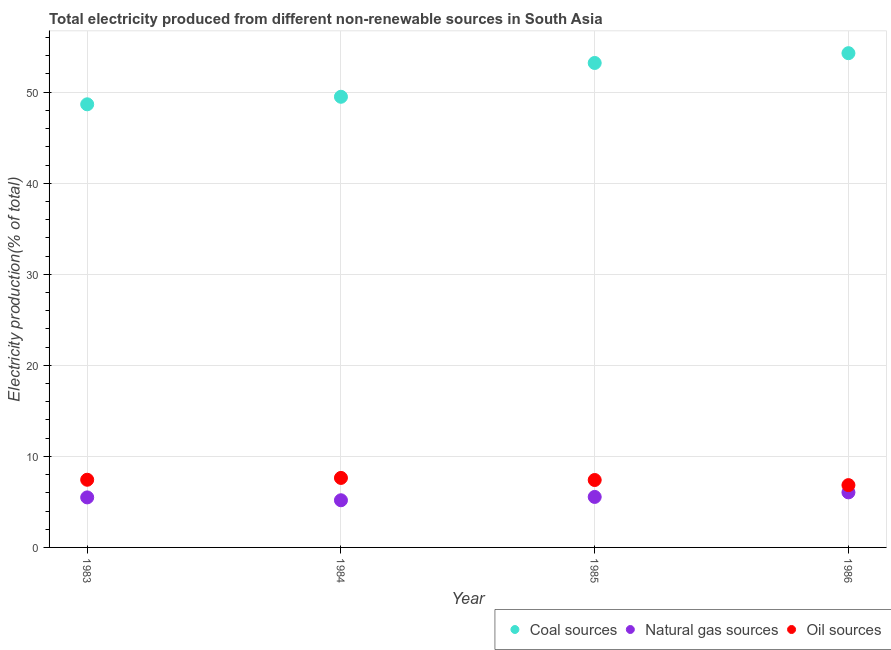How many different coloured dotlines are there?
Provide a succinct answer. 3. What is the percentage of electricity produced by natural gas in 1986?
Your answer should be compact. 6.05. Across all years, what is the maximum percentage of electricity produced by oil sources?
Your response must be concise. 7.63. Across all years, what is the minimum percentage of electricity produced by coal?
Ensure brevity in your answer.  48.67. In which year was the percentage of electricity produced by coal maximum?
Provide a short and direct response. 1986. What is the total percentage of electricity produced by natural gas in the graph?
Your response must be concise. 22.27. What is the difference between the percentage of electricity produced by oil sources in 1984 and that in 1986?
Offer a very short reply. 0.79. What is the difference between the percentage of electricity produced by natural gas in 1983 and the percentage of electricity produced by oil sources in 1984?
Your response must be concise. -2.14. What is the average percentage of electricity produced by oil sources per year?
Your answer should be very brief. 7.33. In the year 1985, what is the difference between the percentage of electricity produced by natural gas and percentage of electricity produced by oil sources?
Make the answer very short. -1.86. What is the ratio of the percentage of electricity produced by natural gas in 1983 to that in 1986?
Your response must be concise. 0.91. Is the percentage of electricity produced by natural gas in 1984 less than that in 1986?
Offer a very short reply. Yes. What is the difference between the highest and the second highest percentage of electricity produced by oil sources?
Ensure brevity in your answer.  0.2. What is the difference between the highest and the lowest percentage of electricity produced by coal?
Your response must be concise. 5.62. In how many years, is the percentage of electricity produced by coal greater than the average percentage of electricity produced by coal taken over all years?
Offer a very short reply. 2. Is the sum of the percentage of electricity produced by coal in 1985 and 1986 greater than the maximum percentage of electricity produced by oil sources across all years?
Keep it short and to the point. Yes. How many dotlines are there?
Offer a terse response. 3. What is the title of the graph?
Your answer should be compact. Total electricity produced from different non-renewable sources in South Asia. What is the label or title of the X-axis?
Keep it short and to the point. Year. What is the label or title of the Y-axis?
Provide a succinct answer. Electricity production(% of total). What is the Electricity production(% of total) in Coal sources in 1983?
Your answer should be compact. 48.67. What is the Electricity production(% of total) of Natural gas sources in 1983?
Offer a terse response. 5.49. What is the Electricity production(% of total) in Oil sources in 1983?
Provide a short and direct response. 7.43. What is the Electricity production(% of total) in Coal sources in 1984?
Offer a very short reply. 49.5. What is the Electricity production(% of total) of Natural gas sources in 1984?
Your answer should be compact. 5.18. What is the Electricity production(% of total) in Oil sources in 1984?
Your response must be concise. 7.63. What is the Electricity production(% of total) in Coal sources in 1985?
Ensure brevity in your answer.  53.21. What is the Electricity production(% of total) in Natural gas sources in 1985?
Offer a very short reply. 5.55. What is the Electricity production(% of total) of Oil sources in 1985?
Your response must be concise. 7.4. What is the Electricity production(% of total) in Coal sources in 1986?
Offer a terse response. 54.29. What is the Electricity production(% of total) of Natural gas sources in 1986?
Your answer should be very brief. 6.05. What is the Electricity production(% of total) of Oil sources in 1986?
Your answer should be very brief. 6.84. Across all years, what is the maximum Electricity production(% of total) of Coal sources?
Give a very brief answer. 54.29. Across all years, what is the maximum Electricity production(% of total) in Natural gas sources?
Offer a very short reply. 6.05. Across all years, what is the maximum Electricity production(% of total) in Oil sources?
Offer a terse response. 7.63. Across all years, what is the minimum Electricity production(% of total) in Coal sources?
Ensure brevity in your answer.  48.67. Across all years, what is the minimum Electricity production(% of total) of Natural gas sources?
Provide a succinct answer. 5.18. Across all years, what is the minimum Electricity production(% of total) of Oil sources?
Offer a terse response. 6.84. What is the total Electricity production(% of total) in Coal sources in the graph?
Give a very brief answer. 205.67. What is the total Electricity production(% of total) of Natural gas sources in the graph?
Offer a very short reply. 22.27. What is the total Electricity production(% of total) in Oil sources in the graph?
Offer a very short reply. 29.32. What is the difference between the Electricity production(% of total) in Coal sources in 1983 and that in 1984?
Offer a terse response. -0.83. What is the difference between the Electricity production(% of total) of Natural gas sources in 1983 and that in 1984?
Your answer should be compact. 0.31. What is the difference between the Electricity production(% of total) of Oil sources in 1983 and that in 1984?
Provide a succinct answer. -0.2. What is the difference between the Electricity production(% of total) in Coal sources in 1983 and that in 1985?
Give a very brief answer. -4.54. What is the difference between the Electricity production(% of total) of Natural gas sources in 1983 and that in 1985?
Give a very brief answer. -0.05. What is the difference between the Electricity production(% of total) of Oil sources in 1983 and that in 1985?
Ensure brevity in your answer.  0.03. What is the difference between the Electricity production(% of total) of Coal sources in 1983 and that in 1986?
Ensure brevity in your answer.  -5.62. What is the difference between the Electricity production(% of total) of Natural gas sources in 1983 and that in 1986?
Provide a succinct answer. -0.55. What is the difference between the Electricity production(% of total) in Oil sources in 1983 and that in 1986?
Provide a succinct answer. 0.59. What is the difference between the Electricity production(% of total) in Coal sources in 1984 and that in 1985?
Offer a terse response. -3.71. What is the difference between the Electricity production(% of total) in Natural gas sources in 1984 and that in 1985?
Offer a very short reply. -0.37. What is the difference between the Electricity production(% of total) in Oil sources in 1984 and that in 1985?
Offer a very short reply. 0.23. What is the difference between the Electricity production(% of total) of Coal sources in 1984 and that in 1986?
Give a very brief answer. -4.79. What is the difference between the Electricity production(% of total) in Natural gas sources in 1984 and that in 1986?
Offer a terse response. -0.87. What is the difference between the Electricity production(% of total) of Oil sources in 1984 and that in 1986?
Provide a short and direct response. 0.79. What is the difference between the Electricity production(% of total) in Coal sources in 1985 and that in 1986?
Give a very brief answer. -1.08. What is the difference between the Electricity production(% of total) of Natural gas sources in 1985 and that in 1986?
Provide a short and direct response. -0.5. What is the difference between the Electricity production(% of total) of Oil sources in 1985 and that in 1986?
Provide a succinct answer. 0.56. What is the difference between the Electricity production(% of total) in Coal sources in 1983 and the Electricity production(% of total) in Natural gas sources in 1984?
Offer a terse response. 43.49. What is the difference between the Electricity production(% of total) of Coal sources in 1983 and the Electricity production(% of total) of Oil sources in 1984?
Ensure brevity in your answer.  41.04. What is the difference between the Electricity production(% of total) in Natural gas sources in 1983 and the Electricity production(% of total) in Oil sources in 1984?
Keep it short and to the point. -2.14. What is the difference between the Electricity production(% of total) in Coal sources in 1983 and the Electricity production(% of total) in Natural gas sources in 1985?
Your answer should be very brief. 43.12. What is the difference between the Electricity production(% of total) of Coal sources in 1983 and the Electricity production(% of total) of Oil sources in 1985?
Provide a succinct answer. 41.27. What is the difference between the Electricity production(% of total) of Natural gas sources in 1983 and the Electricity production(% of total) of Oil sources in 1985?
Offer a terse response. -1.91. What is the difference between the Electricity production(% of total) in Coal sources in 1983 and the Electricity production(% of total) in Natural gas sources in 1986?
Make the answer very short. 42.62. What is the difference between the Electricity production(% of total) in Coal sources in 1983 and the Electricity production(% of total) in Oil sources in 1986?
Offer a very short reply. 41.83. What is the difference between the Electricity production(% of total) of Natural gas sources in 1983 and the Electricity production(% of total) of Oil sources in 1986?
Offer a terse response. -1.35. What is the difference between the Electricity production(% of total) in Coal sources in 1984 and the Electricity production(% of total) in Natural gas sources in 1985?
Give a very brief answer. 43.95. What is the difference between the Electricity production(% of total) in Coal sources in 1984 and the Electricity production(% of total) in Oil sources in 1985?
Provide a short and direct response. 42.09. What is the difference between the Electricity production(% of total) of Natural gas sources in 1984 and the Electricity production(% of total) of Oil sources in 1985?
Ensure brevity in your answer.  -2.22. What is the difference between the Electricity production(% of total) of Coal sources in 1984 and the Electricity production(% of total) of Natural gas sources in 1986?
Your answer should be very brief. 43.45. What is the difference between the Electricity production(% of total) in Coal sources in 1984 and the Electricity production(% of total) in Oil sources in 1986?
Provide a short and direct response. 42.65. What is the difference between the Electricity production(% of total) of Natural gas sources in 1984 and the Electricity production(% of total) of Oil sources in 1986?
Give a very brief answer. -1.66. What is the difference between the Electricity production(% of total) in Coal sources in 1985 and the Electricity production(% of total) in Natural gas sources in 1986?
Your answer should be very brief. 47.16. What is the difference between the Electricity production(% of total) in Coal sources in 1985 and the Electricity production(% of total) in Oil sources in 1986?
Make the answer very short. 46.37. What is the difference between the Electricity production(% of total) in Natural gas sources in 1985 and the Electricity production(% of total) in Oil sources in 1986?
Ensure brevity in your answer.  -1.3. What is the average Electricity production(% of total) of Coal sources per year?
Your answer should be very brief. 51.42. What is the average Electricity production(% of total) of Natural gas sources per year?
Keep it short and to the point. 5.57. What is the average Electricity production(% of total) in Oil sources per year?
Give a very brief answer. 7.33. In the year 1983, what is the difference between the Electricity production(% of total) in Coal sources and Electricity production(% of total) in Natural gas sources?
Your answer should be compact. 43.18. In the year 1983, what is the difference between the Electricity production(% of total) in Coal sources and Electricity production(% of total) in Oil sources?
Make the answer very short. 41.24. In the year 1983, what is the difference between the Electricity production(% of total) of Natural gas sources and Electricity production(% of total) of Oil sources?
Ensure brevity in your answer.  -1.94. In the year 1984, what is the difference between the Electricity production(% of total) in Coal sources and Electricity production(% of total) in Natural gas sources?
Give a very brief answer. 44.32. In the year 1984, what is the difference between the Electricity production(% of total) of Coal sources and Electricity production(% of total) of Oil sources?
Your answer should be compact. 41.86. In the year 1984, what is the difference between the Electricity production(% of total) in Natural gas sources and Electricity production(% of total) in Oil sources?
Ensure brevity in your answer.  -2.45. In the year 1985, what is the difference between the Electricity production(% of total) of Coal sources and Electricity production(% of total) of Natural gas sources?
Your response must be concise. 47.66. In the year 1985, what is the difference between the Electricity production(% of total) of Coal sources and Electricity production(% of total) of Oil sources?
Offer a terse response. 45.81. In the year 1985, what is the difference between the Electricity production(% of total) in Natural gas sources and Electricity production(% of total) in Oil sources?
Make the answer very short. -1.86. In the year 1986, what is the difference between the Electricity production(% of total) in Coal sources and Electricity production(% of total) in Natural gas sources?
Your response must be concise. 48.24. In the year 1986, what is the difference between the Electricity production(% of total) of Coal sources and Electricity production(% of total) of Oil sources?
Offer a terse response. 47.44. In the year 1986, what is the difference between the Electricity production(% of total) in Natural gas sources and Electricity production(% of total) in Oil sources?
Keep it short and to the point. -0.8. What is the ratio of the Electricity production(% of total) of Coal sources in 1983 to that in 1984?
Provide a short and direct response. 0.98. What is the ratio of the Electricity production(% of total) of Natural gas sources in 1983 to that in 1984?
Give a very brief answer. 1.06. What is the ratio of the Electricity production(% of total) of Oil sources in 1983 to that in 1984?
Ensure brevity in your answer.  0.97. What is the ratio of the Electricity production(% of total) of Coal sources in 1983 to that in 1985?
Ensure brevity in your answer.  0.91. What is the ratio of the Electricity production(% of total) in Natural gas sources in 1983 to that in 1985?
Your response must be concise. 0.99. What is the ratio of the Electricity production(% of total) of Oil sources in 1983 to that in 1985?
Your response must be concise. 1. What is the ratio of the Electricity production(% of total) in Coal sources in 1983 to that in 1986?
Your answer should be compact. 0.9. What is the ratio of the Electricity production(% of total) of Natural gas sources in 1983 to that in 1986?
Your response must be concise. 0.91. What is the ratio of the Electricity production(% of total) in Oil sources in 1983 to that in 1986?
Give a very brief answer. 1.09. What is the ratio of the Electricity production(% of total) in Coal sources in 1984 to that in 1985?
Make the answer very short. 0.93. What is the ratio of the Electricity production(% of total) in Natural gas sources in 1984 to that in 1985?
Offer a terse response. 0.93. What is the ratio of the Electricity production(% of total) of Oil sources in 1984 to that in 1985?
Ensure brevity in your answer.  1.03. What is the ratio of the Electricity production(% of total) of Coal sources in 1984 to that in 1986?
Give a very brief answer. 0.91. What is the ratio of the Electricity production(% of total) in Natural gas sources in 1984 to that in 1986?
Offer a very short reply. 0.86. What is the ratio of the Electricity production(% of total) of Oil sources in 1984 to that in 1986?
Your response must be concise. 1.12. What is the ratio of the Electricity production(% of total) of Coal sources in 1985 to that in 1986?
Your answer should be very brief. 0.98. What is the ratio of the Electricity production(% of total) in Natural gas sources in 1985 to that in 1986?
Offer a terse response. 0.92. What is the ratio of the Electricity production(% of total) of Oil sources in 1985 to that in 1986?
Give a very brief answer. 1.08. What is the difference between the highest and the second highest Electricity production(% of total) in Coal sources?
Offer a very short reply. 1.08. What is the difference between the highest and the second highest Electricity production(% of total) in Natural gas sources?
Provide a succinct answer. 0.5. What is the difference between the highest and the second highest Electricity production(% of total) in Oil sources?
Keep it short and to the point. 0.2. What is the difference between the highest and the lowest Electricity production(% of total) in Coal sources?
Your answer should be very brief. 5.62. What is the difference between the highest and the lowest Electricity production(% of total) in Natural gas sources?
Offer a very short reply. 0.87. What is the difference between the highest and the lowest Electricity production(% of total) in Oil sources?
Keep it short and to the point. 0.79. 